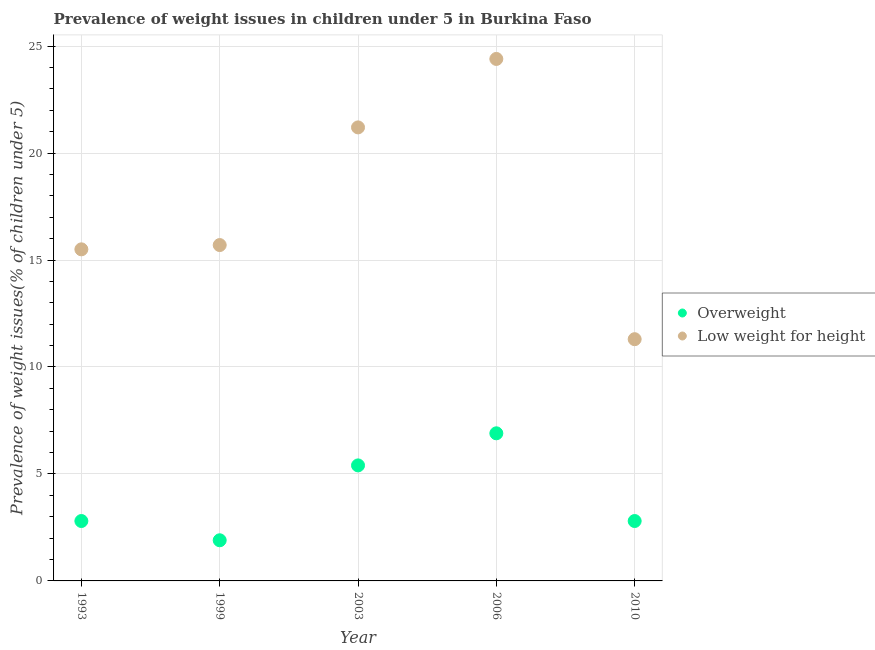How many different coloured dotlines are there?
Your response must be concise. 2. Is the number of dotlines equal to the number of legend labels?
Ensure brevity in your answer.  Yes. What is the percentage of overweight children in 2010?
Provide a succinct answer. 2.8. Across all years, what is the maximum percentage of underweight children?
Ensure brevity in your answer.  24.4. Across all years, what is the minimum percentage of underweight children?
Provide a succinct answer. 11.3. In which year was the percentage of underweight children minimum?
Offer a very short reply. 2010. What is the total percentage of underweight children in the graph?
Provide a short and direct response. 88.1. What is the difference between the percentage of underweight children in 1999 and that in 2010?
Keep it short and to the point. 4.4. What is the difference between the percentage of underweight children in 2006 and the percentage of overweight children in 1999?
Keep it short and to the point. 22.5. What is the average percentage of underweight children per year?
Provide a short and direct response. 17.62. In the year 1993, what is the difference between the percentage of underweight children and percentage of overweight children?
Your answer should be very brief. 12.7. In how many years, is the percentage of overweight children greater than 12 %?
Provide a short and direct response. 0. What is the ratio of the percentage of overweight children in 1993 to that in 2006?
Give a very brief answer. 0.41. Is the difference between the percentage of overweight children in 1999 and 2010 greater than the difference between the percentage of underweight children in 1999 and 2010?
Your answer should be very brief. No. What is the difference between the highest and the lowest percentage of underweight children?
Provide a short and direct response. 13.1. Is the sum of the percentage of underweight children in 1993 and 2010 greater than the maximum percentage of overweight children across all years?
Offer a terse response. Yes. Is the percentage of overweight children strictly greater than the percentage of underweight children over the years?
Give a very brief answer. No. How many dotlines are there?
Offer a very short reply. 2. What is the difference between two consecutive major ticks on the Y-axis?
Your answer should be compact. 5. Does the graph contain grids?
Provide a succinct answer. Yes. Where does the legend appear in the graph?
Make the answer very short. Center right. What is the title of the graph?
Provide a short and direct response. Prevalence of weight issues in children under 5 in Burkina Faso. Does "From World Bank" appear as one of the legend labels in the graph?
Make the answer very short. No. What is the label or title of the Y-axis?
Keep it short and to the point. Prevalence of weight issues(% of children under 5). What is the Prevalence of weight issues(% of children under 5) of Overweight in 1993?
Your response must be concise. 2.8. What is the Prevalence of weight issues(% of children under 5) of Low weight for height in 1993?
Your answer should be very brief. 15.5. What is the Prevalence of weight issues(% of children under 5) of Overweight in 1999?
Make the answer very short. 1.9. What is the Prevalence of weight issues(% of children under 5) in Low weight for height in 1999?
Keep it short and to the point. 15.7. What is the Prevalence of weight issues(% of children under 5) of Overweight in 2003?
Offer a very short reply. 5.4. What is the Prevalence of weight issues(% of children under 5) in Low weight for height in 2003?
Provide a short and direct response. 21.2. What is the Prevalence of weight issues(% of children under 5) in Overweight in 2006?
Provide a short and direct response. 6.9. What is the Prevalence of weight issues(% of children under 5) in Low weight for height in 2006?
Keep it short and to the point. 24.4. What is the Prevalence of weight issues(% of children under 5) of Overweight in 2010?
Your answer should be compact. 2.8. What is the Prevalence of weight issues(% of children under 5) of Low weight for height in 2010?
Your response must be concise. 11.3. Across all years, what is the maximum Prevalence of weight issues(% of children under 5) of Overweight?
Offer a terse response. 6.9. Across all years, what is the maximum Prevalence of weight issues(% of children under 5) of Low weight for height?
Your answer should be very brief. 24.4. Across all years, what is the minimum Prevalence of weight issues(% of children under 5) of Overweight?
Make the answer very short. 1.9. Across all years, what is the minimum Prevalence of weight issues(% of children under 5) in Low weight for height?
Keep it short and to the point. 11.3. What is the total Prevalence of weight issues(% of children under 5) in Overweight in the graph?
Your response must be concise. 19.8. What is the total Prevalence of weight issues(% of children under 5) of Low weight for height in the graph?
Keep it short and to the point. 88.1. What is the difference between the Prevalence of weight issues(% of children under 5) in Overweight in 1993 and that in 2003?
Offer a terse response. -2.6. What is the difference between the Prevalence of weight issues(% of children under 5) of Overweight in 1993 and that in 2010?
Make the answer very short. 0. What is the difference between the Prevalence of weight issues(% of children under 5) of Low weight for height in 1993 and that in 2010?
Your answer should be very brief. 4.2. What is the difference between the Prevalence of weight issues(% of children under 5) of Overweight in 1999 and that in 2003?
Make the answer very short. -3.5. What is the difference between the Prevalence of weight issues(% of children under 5) in Overweight in 2006 and that in 2010?
Your response must be concise. 4.1. What is the difference between the Prevalence of weight issues(% of children under 5) of Overweight in 1993 and the Prevalence of weight issues(% of children under 5) of Low weight for height in 1999?
Give a very brief answer. -12.9. What is the difference between the Prevalence of weight issues(% of children under 5) of Overweight in 1993 and the Prevalence of weight issues(% of children under 5) of Low weight for height in 2003?
Make the answer very short. -18.4. What is the difference between the Prevalence of weight issues(% of children under 5) of Overweight in 1993 and the Prevalence of weight issues(% of children under 5) of Low weight for height in 2006?
Your answer should be compact. -21.6. What is the difference between the Prevalence of weight issues(% of children under 5) of Overweight in 1999 and the Prevalence of weight issues(% of children under 5) of Low weight for height in 2003?
Ensure brevity in your answer.  -19.3. What is the difference between the Prevalence of weight issues(% of children under 5) of Overweight in 1999 and the Prevalence of weight issues(% of children under 5) of Low weight for height in 2006?
Your answer should be compact. -22.5. What is the difference between the Prevalence of weight issues(% of children under 5) in Overweight in 1999 and the Prevalence of weight issues(% of children under 5) in Low weight for height in 2010?
Offer a very short reply. -9.4. What is the difference between the Prevalence of weight issues(% of children under 5) of Overweight in 2003 and the Prevalence of weight issues(% of children under 5) of Low weight for height in 2006?
Give a very brief answer. -19. What is the difference between the Prevalence of weight issues(% of children under 5) in Overweight in 2003 and the Prevalence of weight issues(% of children under 5) in Low weight for height in 2010?
Offer a very short reply. -5.9. What is the difference between the Prevalence of weight issues(% of children under 5) of Overweight in 2006 and the Prevalence of weight issues(% of children under 5) of Low weight for height in 2010?
Keep it short and to the point. -4.4. What is the average Prevalence of weight issues(% of children under 5) of Overweight per year?
Provide a short and direct response. 3.96. What is the average Prevalence of weight issues(% of children under 5) in Low weight for height per year?
Ensure brevity in your answer.  17.62. In the year 1993, what is the difference between the Prevalence of weight issues(% of children under 5) in Overweight and Prevalence of weight issues(% of children under 5) in Low weight for height?
Your answer should be very brief. -12.7. In the year 1999, what is the difference between the Prevalence of weight issues(% of children under 5) in Overweight and Prevalence of weight issues(% of children under 5) in Low weight for height?
Offer a terse response. -13.8. In the year 2003, what is the difference between the Prevalence of weight issues(% of children under 5) in Overweight and Prevalence of weight issues(% of children under 5) in Low weight for height?
Make the answer very short. -15.8. In the year 2006, what is the difference between the Prevalence of weight issues(% of children under 5) in Overweight and Prevalence of weight issues(% of children under 5) in Low weight for height?
Your response must be concise. -17.5. In the year 2010, what is the difference between the Prevalence of weight issues(% of children under 5) of Overweight and Prevalence of weight issues(% of children under 5) of Low weight for height?
Ensure brevity in your answer.  -8.5. What is the ratio of the Prevalence of weight issues(% of children under 5) of Overweight in 1993 to that in 1999?
Give a very brief answer. 1.47. What is the ratio of the Prevalence of weight issues(% of children under 5) of Low weight for height in 1993 to that in 1999?
Provide a succinct answer. 0.99. What is the ratio of the Prevalence of weight issues(% of children under 5) in Overweight in 1993 to that in 2003?
Ensure brevity in your answer.  0.52. What is the ratio of the Prevalence of weight issues(% of children under 5) in Low weight for height in 1993 to that in 2003?
Make the answer very short. 0.73. What is the ratio of the Prevalence of weight issues(% of children under 5) in Overweight in 1993 to that in 2006?
Your answer should be very brief. 0.41. What is the ratio of the Prevalence of weight issues(% of children under 5) in Low weight for height in 1993 to that in 2006?
Ensure brevity in your answer.  0.64. What is the ratio of the Prevalence of weight issues(% of children under 5) of Low weight for height in 1993 to that in 2010?
Offer a very short reply. 1.37. What is the ratio of the Prevalence of weight issues(% of children under 5) of Overweight in 1999 to that in 2003?
Provide a short and direct response. 0.35. What is the ratio of the Prevalence of weight issues(% of children under 5) of Low weight for height in 1999 to that in 2003?
Your answer should be compact. 0.74. What is the ratio of the Prevalence of weight issues(% of children under 5) in Overweight in 1999 to that in 2006?
Provide a short and direct response. 0.28. What is the ratio of the Prevalence of weight issues(% of children under 5) in Low weight for height in 1999 to that in 2006?
Make the answer very short. 0.64. What is the ratio of the Prevalence of weight issues(% of children under 5) in Overweight in 1999 to that in 2010?
Your answer should be compact. 0.68. What is the ratio of the Prevalence of weight issues(% of children under 5) of Low weight for height in 1999 to that in 2010?
Give a very brief answer. 1.39. What is the ratio of the Prevalence of weight issues(% of children under 5) in Overweight in 2003 to that in 2006?
Offer a very short reply. 0.78. What is the ratio of the Prevalence of weight issues(% of children under 5) of Low weight for height in 2003 to that in 2006?
Offer a terse response. 0.87. What is the ratio of the Prevalence of weight issues(% of children under 5) in Overweight in 2003 to that in 2010?
Ensure brevity in your answer.  1.93. What is the ratio of the Prevalence of weight issues(% of children under 5) in Low weight for height in 2003 to that in 2010?
Give a very brief answer. 1.88. What is the ratio of the Prevalence of weight issues(% of children under 5) in Overweight in 2006 to that in 2010?
Ensure brevity in your answer.  2.46. What is the ratio of the Prevalence of weight issues(% of children under 5) in Low weight for height in 2006 to that in 2010?
Your answer should be compact. 2.16. What is the difference between the highest and the lowest Prevalence of weight issues(% of children under 5) of Low weight for height?
Give a very brief answer. 13.1. 